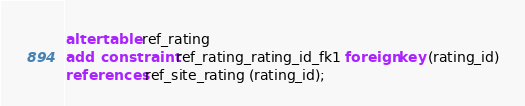Convert code to text. <code><loc_0><loc_0><loc_500><loc_500><_SQL_>alter table ref_rating 
add  constraint ref_rating_rating_id_fk1 foreign key (rating_id)
references ref_site_rating (rating_id);
</code> 